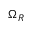Convert formula to latex. <formula><loc_0><loc_0><loc_500><loc_500>\Omega _ { R }</formula> 